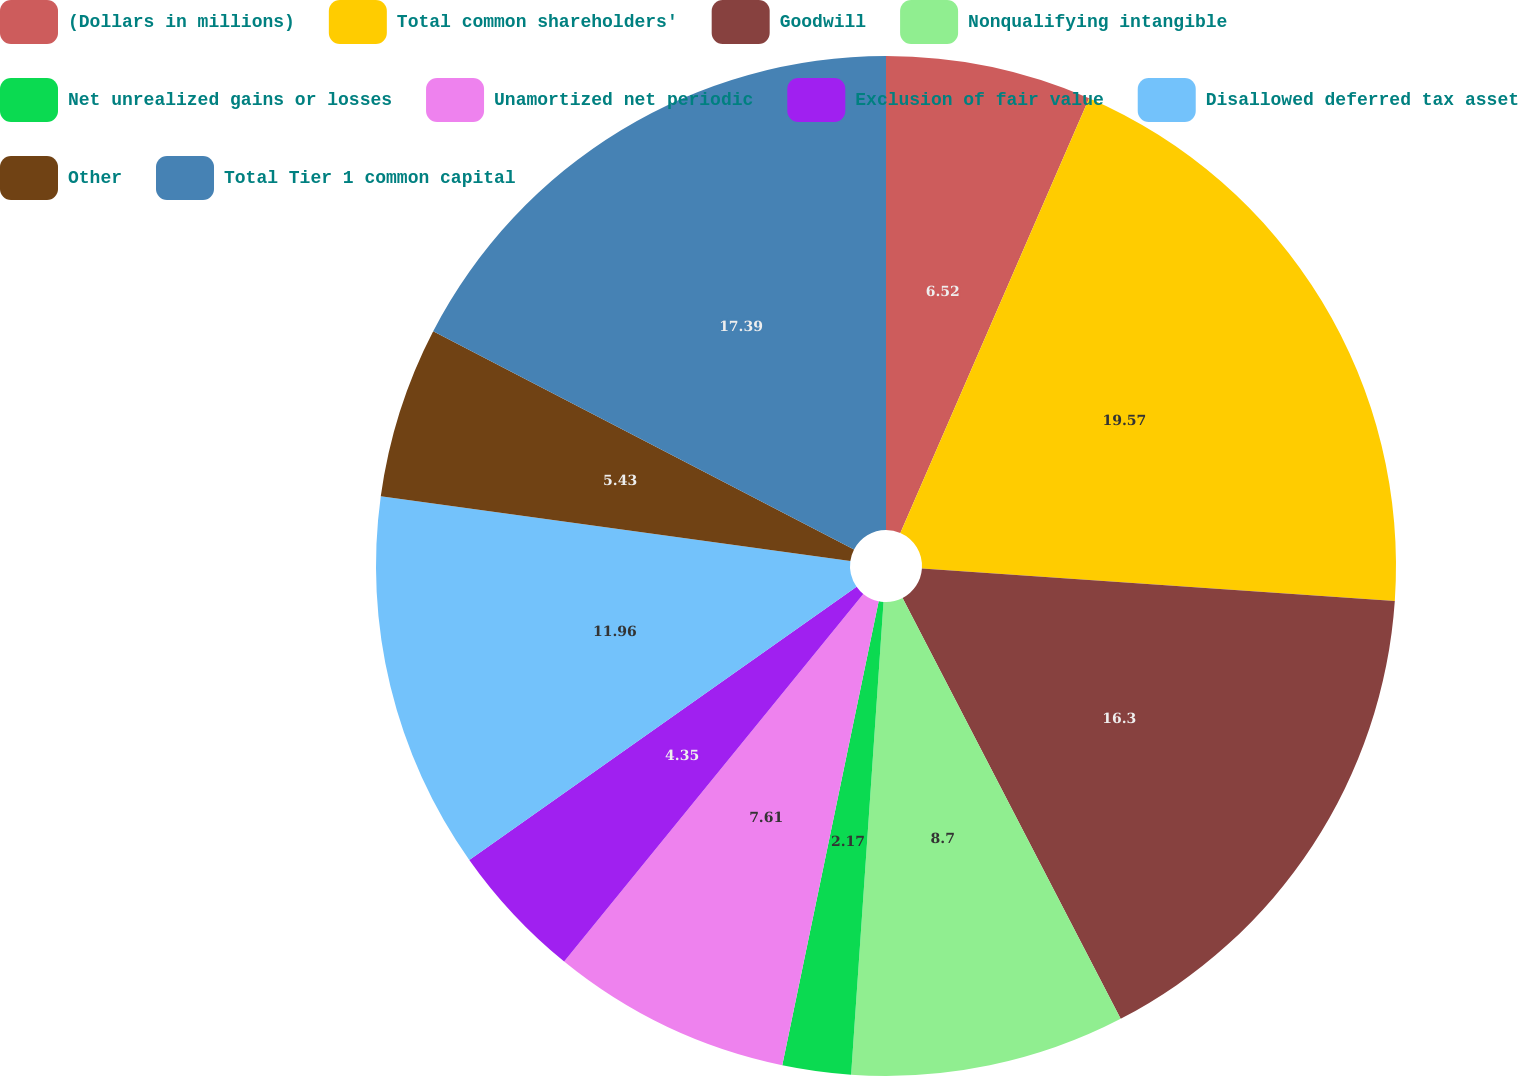Convert chart. <chart><loc_0><loc_0><loc_500><loc_500><pie_chart><fcel>(Dollars in millions)<fcel>Total common shareholders'<fcel>Goodwill<fcel>Nonqualifying intangible<fcel>Net unrealized gains or losses<fcel>Unamortized net periodic<fcel>Exclusion of fair value<fcel>Disallowed deferred tax asset<fcel>Other<fcel>Total Tier 1 common capital<nl><fcel>6.52%<fcel>19.57%<fcel>16.3%<fcel>8.7%<fcel>2.17%<fcel>7.61%<fcel>4.35%<fcel>11.96%<fcel>5.43%<fcel>17.39%<nl></chart> 